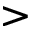<formula> <loc_0><loc_0><loc_500><loc_500>></formula> 